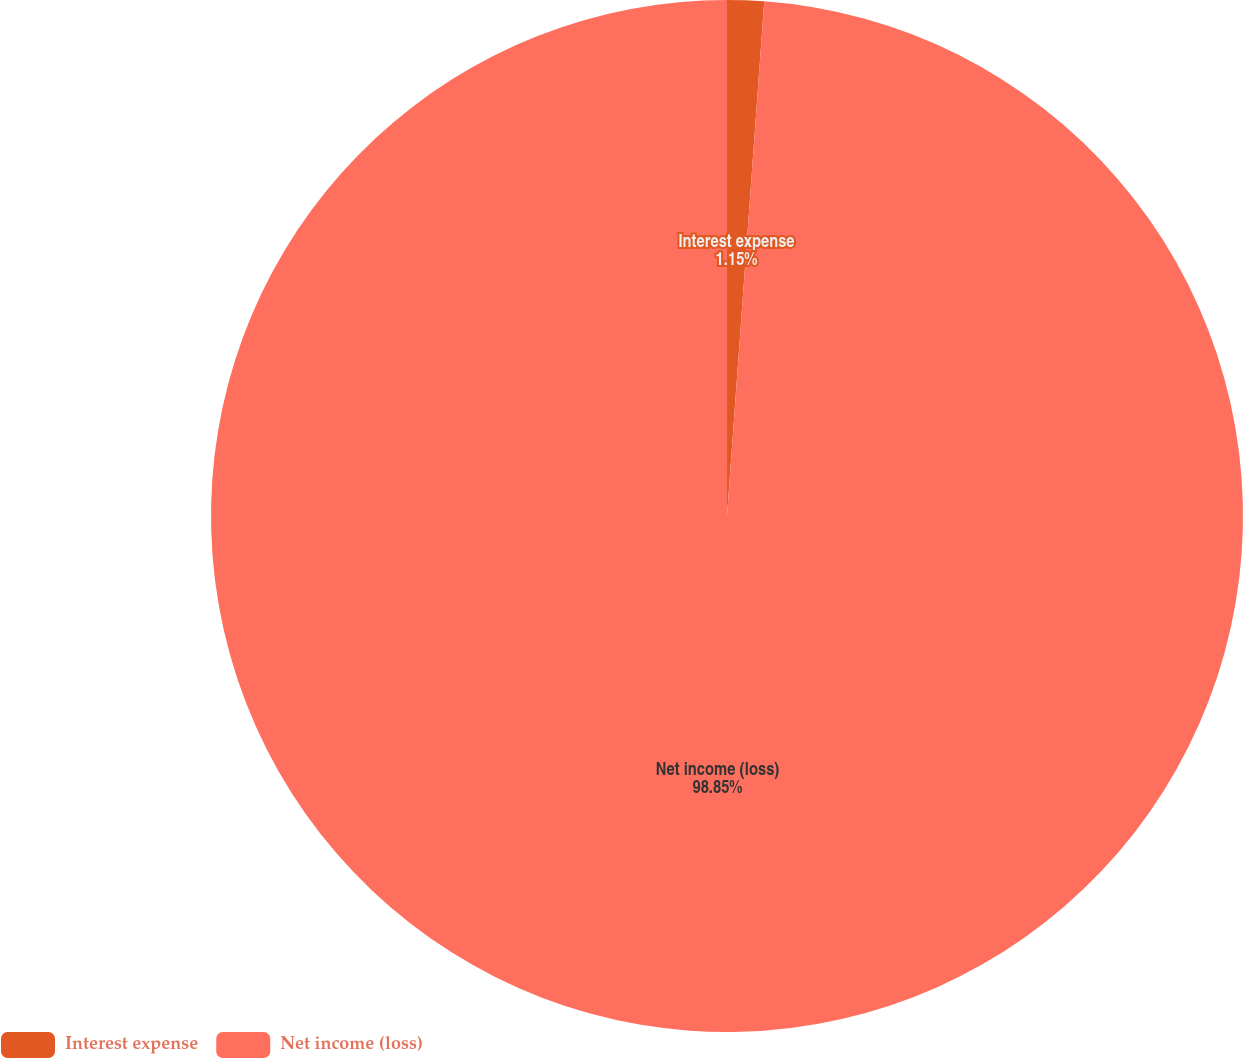Convert chart. <chart><loc_0><loc_0><loc_500><loc_500><pie_chart><fcel>Interest expense<fcel>Net income (loss)<nl><fcel>1.15%<fcel>98.85%<nl></chart> 